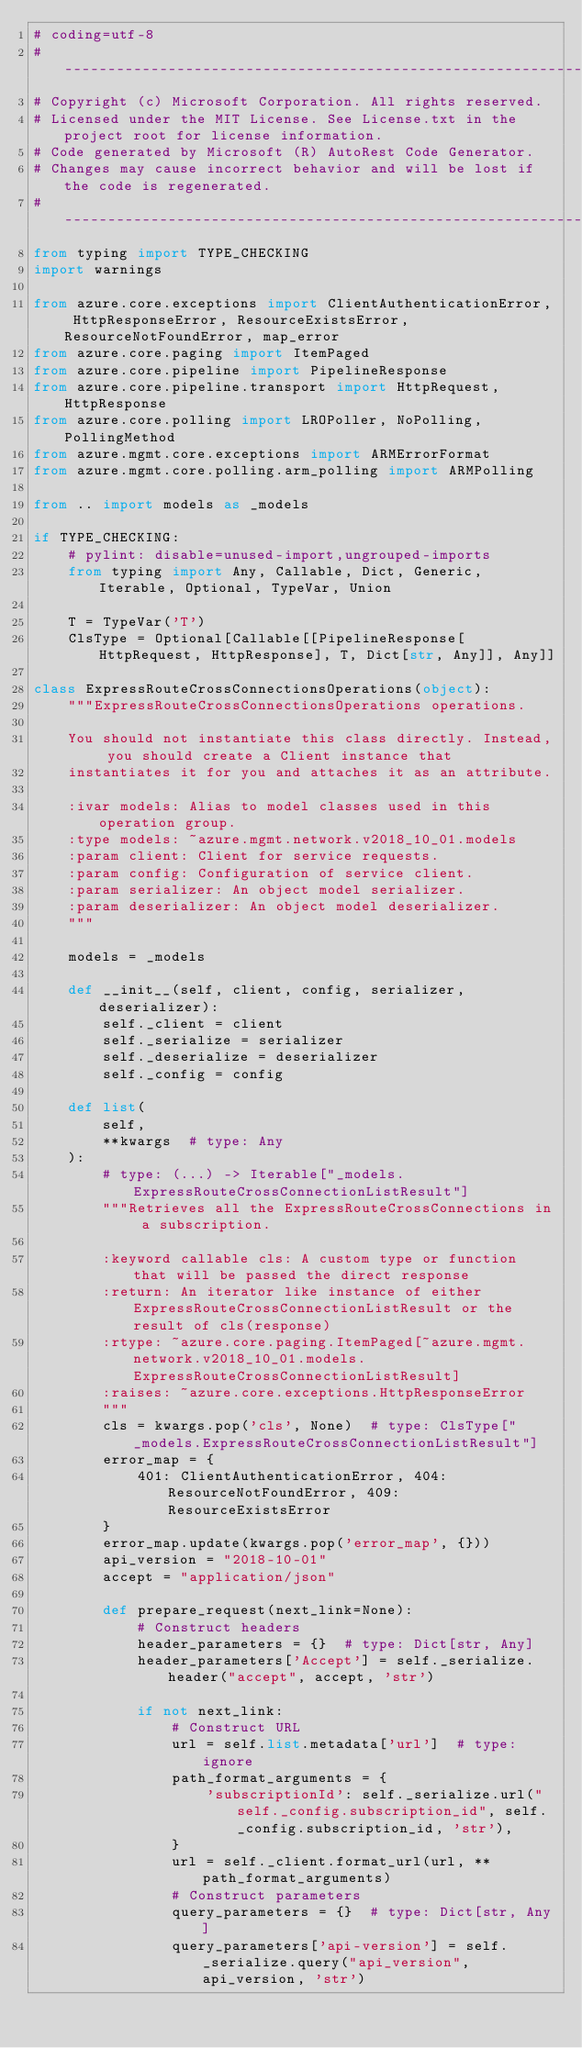<code> <loc_0><loc_0><loc_500><loc_500><_Python_># coding=utf-8
# --------------------------------------------------------------------------
# Copyright (c) Microsoft Corporation. All rights reserved.
# Licensed under the MIT License. See License.txt in the project root for license information.
# Code generated by Microsoft (R) AutoRest Code Generator.
# Changes may cause incorrect behavior and will be lost if the code is regenerated.
# --------------------------------------------------------------------------
from typing import TYPE_CHECKING
import warnings

from azure.core.exceptions import ClientAuthenticationError, HttpResponseError, ResourceExistsError, ResourceNotFoundError, map_error
from azure.core.paging import ItemPaged
from azure.core.pipeline import PipelineResponse
from azure.core.pipeline.transport import HttpRequest, HttpResponse
from azure.core.polling import LROPoller, NoPolling, PollingMethod
from azure.mgmt.core.exceptions import ARMErrorFormat
from azure.mgmt.core.polling.arm_polling import ARMPolling

from .. import models as _models

if TYPE_CHECKING:
    # pylint: disable=unused-import,ungrouped-imports
    from typing import Any, Callable, Dict, Generic, Iterable, Optional, TypeVar, Union

    T = TypeVar('T')
    ClsType = Optional[Callable[[PipelineResponse[HttpRequest, HttpResponse], T, Dict[str, Any]], Any]]

class ExpressRouteCrossConnectionsOperations(object):
    """ExpressRouteCrossConnectionsOperations operations.

    You should not instantiate this class directly. Instead, you should create a Client instance that
    instantiates it for you and attaches it as an attribute.

    :ivar models: Alias to model classes used in this operation group.
    :type models: ~azure.mgmt.network.v2018_10_01.models
    :param client: Client for service requests.
    :param config: Configuration of service client.
    :param serializer: An object model serializer.
    :param deserializer: An object model deserializer.
    """

    models = _models

    def __init__(self, client, config, serializer, deserializer):
        self._client = client
        self._serialize = serializer
        self._deserialize = deserializer
        self._config = config

    def list(
        self,
        **kwargs  # type: Any
    ):
        # type: (...) -> Iterable["_models.ExpressRouteCrossConnectionListResult"]
        """Retrieves all the ExpressRouteCrossConnections in a subscription.

        :keyword callable cls: A custom type or function that will be passed the direct response
        :return: An iterator like instance of either ExpressRouteCrossConnectionListResult or the result of cls(response)
        :rtype: ~azure.core.paging.ItemPaged[~azure.mgmt.network.v2018_10_01.models.ExpressRouteCrossConnectionListResult]
        :raises: ~azure.core.exceptions.HttpResponseError
        """
        cls = kwargs.pop('cls', None)  # type: ClsType["_models.ExpressRouteCrossConnectionListResult"]
        error_map = {
            401: ClientAuthenticationError, 404: ResourceNotFoundError, 409: ResourceExistsError
        }
        error_map.update(kwargs.pop('error_map', {}))
        api_version = "2018-10-01"
        accept = "application/json"

        def prepare_request(next_link=None):
            # Construct headers
            header_parameters = {}  # type: Dict[str, Any]
            header_parameters['Accept'] = self._serialize.header("accept", accept, 'str')

            if not next_link:
                # Construct URL
                url = self.list.metadata['url']  # type: ignore
                path_format_arguments = {
                    'subscriptionId': self._serialize.url("self._config.subscription_id", self._config.subscription_id, 'str'),
                }
                url = self._client.format_url(url, **path_format_arguments)
                # Construct parameters
                query_parameters = {}  # type: Dict[str, Any]
                query_parameters['api-version'] = self._serialize.query("api_version", api_version, 'str')
</code> 